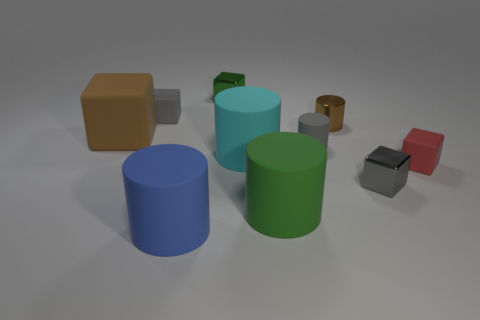Is the number of matte objects in front of the tiny gray metal object greater than the number of red metallic spheres?
Make the answer very short. Yes. Are there any other things that are the same material as the cyan thing?
Your answer should be very brief. Yes. There is a shiny cube to the right of the green block; is its color the same as the rubber cube on the right side of the tiny brown thing?
Your answer should be compact. No. There is a green object in front of the small shiny block that is right of the green object that is to the left of the big green cylinder; what is it made of?
Offer a very short reply. Rubber. Is the number of tiny yellow matte cylinders greater than the number of big brown cubes?
Provide a short and direct response. No. Is there anything else of the same color as the large cube?
Ensure brevity in your answer.  Yes. There is a gray thing that is the same material as the tiny green object; what is its size?
Ensure brevity in your answer.  Small. What is the material of the red object?
Your answer should be very brief. Rubber. How many red matte cylinders are the same size as the green rubber thing?
Provide a short and direct response. 0. There is a big rubber object that is the same color as the metal cylinder; what shape is it?
Provide a succinct answer. Cube. 